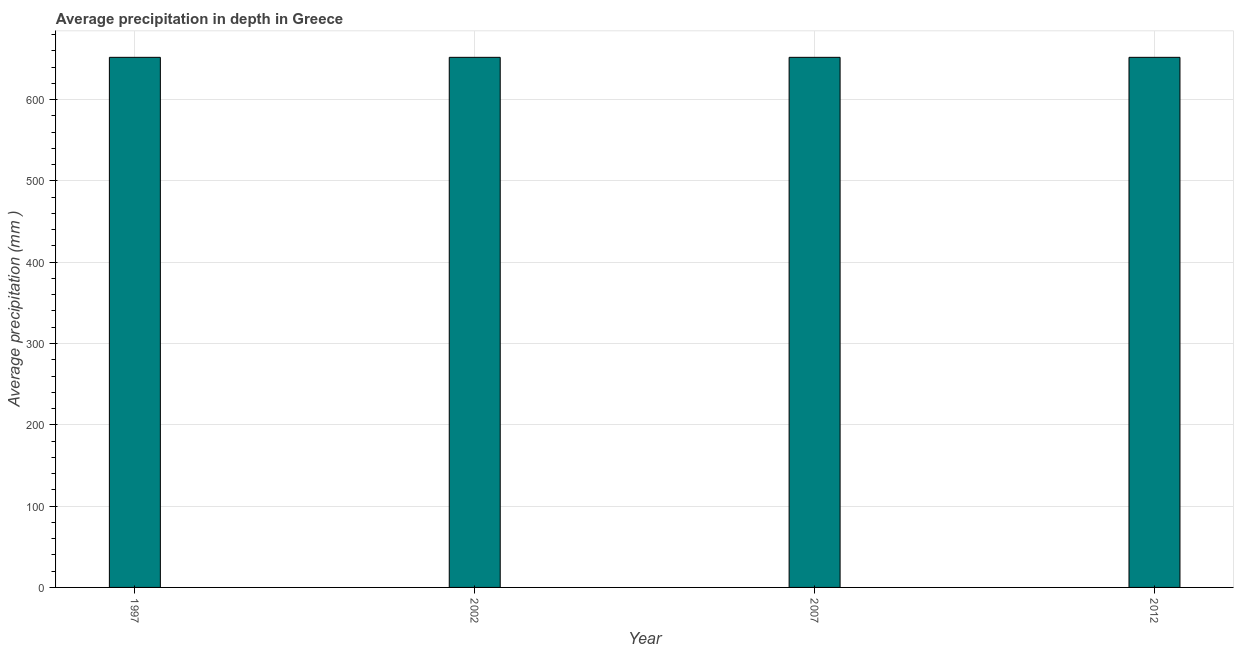Does the graph contain any zero values?
Provide a succinct answer. No. What is the title of the graph?
Your answer should be very brief. Average precipitation in depth in Greece. What is the label or title of the X-axis?
Give a very brief answer. Year. What is the label or title of the Y-axis?
Offer a very short reply. Average precipitation (mm ). What is the average precipitation in depth in 1997?
Your response must be concise. 652. Across all years, what is the maximum average precipitation in depth?
Give a very brief answer. 652. Across all years, what is the minimum average precipitation in depth?
Your response must be concise. 652. What is the sum of the average precipitation in depth?
Provide a succinct answer. 2608. What is the average average precipitation in depth per year?
Offer a very short reply. 652. What is the median average precipitation in depth?
Your response must be concise. 652. In how many years, is the average precipitation in depth greater than 180 mm?
Your answer should be compact. 4. Is the average precipitation in depth in 1997 less than that in 2007?
Provide a short and direct response. No. Is the difference between the average precipitation in depth in 1997 and 2012 greater than the difference between any two years?
Offer a terse response. Yes. Is the sum of the average precipitation in depth in 1997 and 2007 greater than the maximum average precipitation in depth across all years?
Offer a terse response. Yes. What is the difference between the highest and the lowest average precipitation in depth?
Give a very brief answer. 0. How many bars are there?
Offer a terse response. 4. Are all the bars in the graph horizontal?
Keep it short and to the point. No. How many years are there in the graph?
Make the answer very short. 4. What is the difference between two consecutive major ticks on the Y-axis?
Your answer should be very brief. 100. Are the values on the major ticks of Y-axis written in scientific E-notation?
Your answer should be compact. No. What is the Average precipitation (mm ) in 1997?
Your answer should be compact. 652. What is the Average precipitation (mm ) of 2002?
Give a very brief answer. 652. What is the Average precipitation (mm ) in 2007?
Provide a succinct answer. 652. What is the Average precipitation (mm ) of 2012?
Your answer should be compact. 652. What is the difference between the Average precipitation (mm ) in 1997 and 2002?
Provide a short and direct response. 0. What is the difference between the Average precipitation (mm ) in 1997 and 2012?
Give a very brief answer. 0. What is the difference between the Average precipitation (mm ) in 2002 and 2012?
Offer a terse response. 0. What is the ratio of the Average precipitation (mm ) in 1997 to that in 2002?
Your answer should be very brief. 1. What is the ratio of the Average precipitation (mm ) in 1997 to that in 2012?
Offer a very short reply. 1. What is the ratio of the Average precipitation (mm ) in 2002 to that in 2007?
Ensure brevity in your answer.  1. What is the ratio of the Average precipitation (mm ) in 2002 to that in 2012?
Give a very brief answer. 1. 